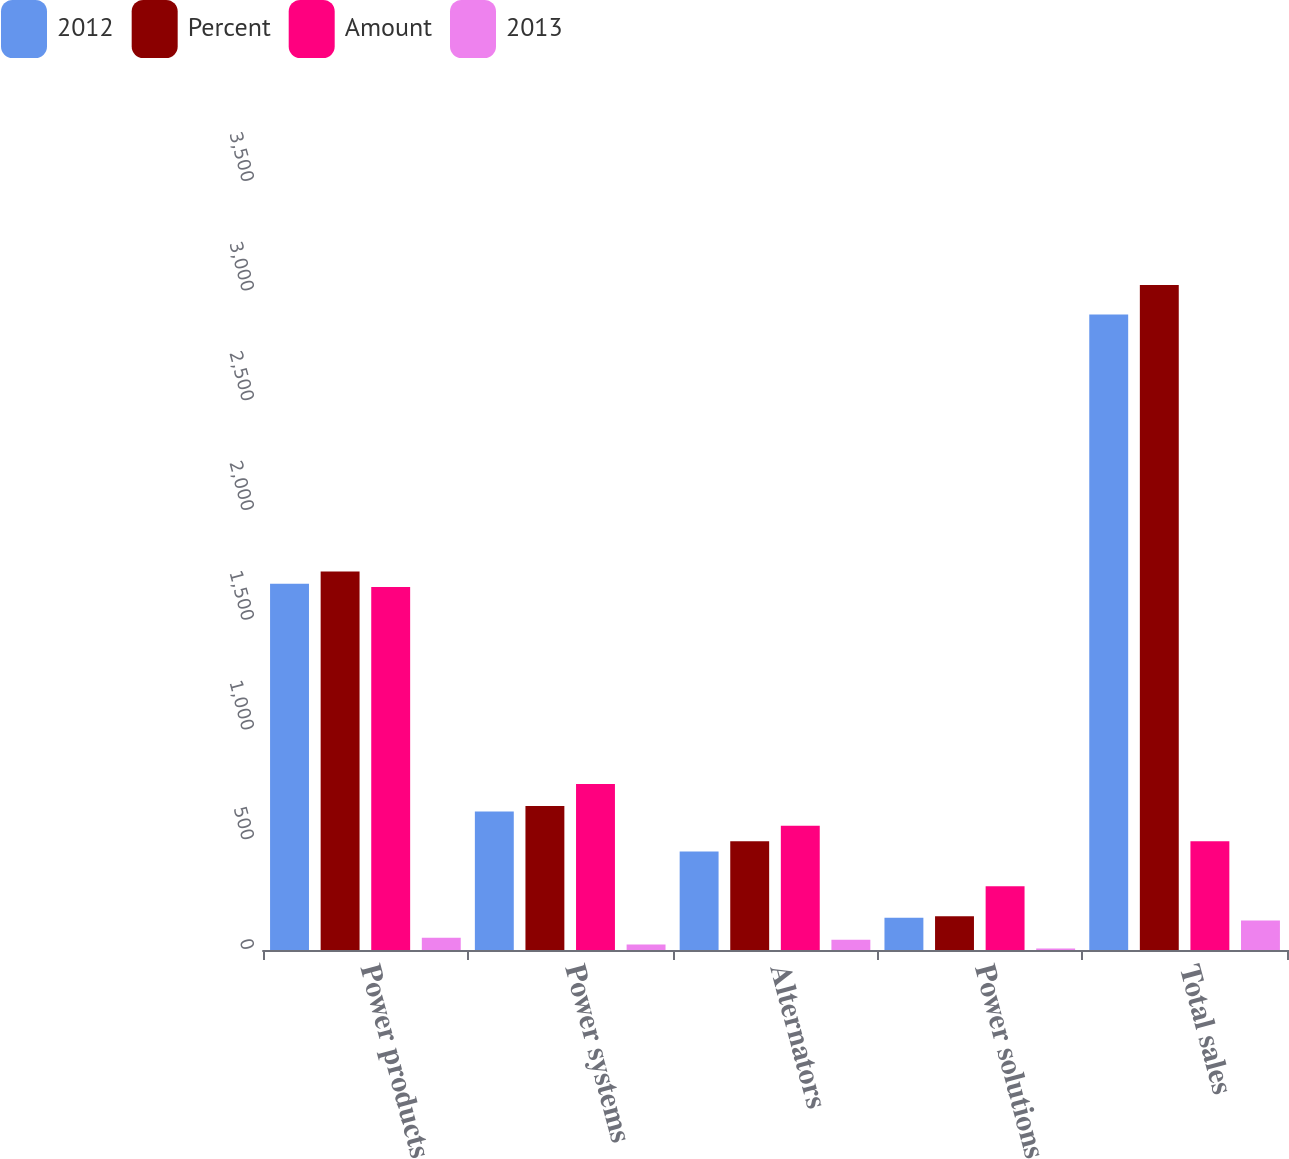Convert chart to OTSL. <chart><loc_0><loc_0><loc_500><loc_500><stacked_bar_chart><ecel><fcel>Power products<fcel>Power systems<fcel>Alternators<fcel>Power solutions<fcel>Total sales<nl><fcel>2012<fcel>1669<fcel>631<fcel>449<fcel>147<fcel>2896<nl><fcel>Percent<fcel>1725<fcel>656<fcel>496<fcel>154<fcel>3031<nl><fcel>Amount<fcel>1654<fcel>757<fcel>566<fcel>291<fcel>496<nl><fcel>2013<fcel>56<fcel>25<fcel>47<fcel>7<fcel>135<nl></chart> 